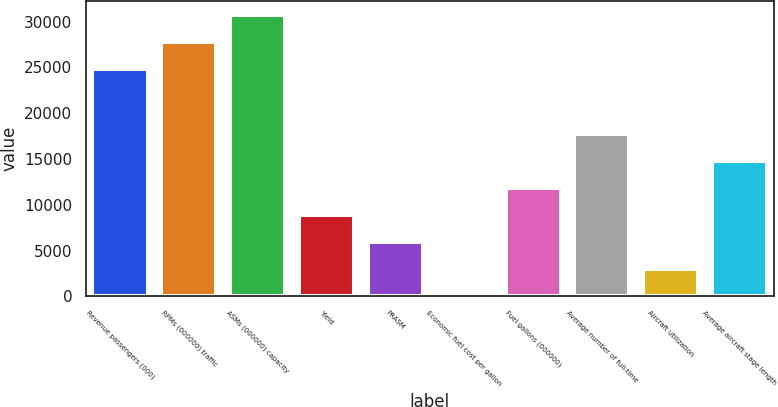Convert chart to OTSL. <chart><loc_0><loc_0><loc_500><loc_500><bar_chart><fcel>Revenue passengers (000)<fcel>RPMs (000000) traffic<fcel>ASMs (000000) capacity<fcel>Yield<fcel>PRASM<fcel>Economic fuel cost per gallon<fcel>Fuel gallons (000000)<fcel>Average number of full-time<fcel>Aircraft utilization<fcel>Average aircraft stage length<nl><fcel>24790<fcel>27752.4<fcel>30714.8<fcel>8890.32<fcel>5927.94<fcel>3.18<fcel>11852.7<fcel>17777.5<fcel>2965.56<fcel>14815.1<nl></chart> 